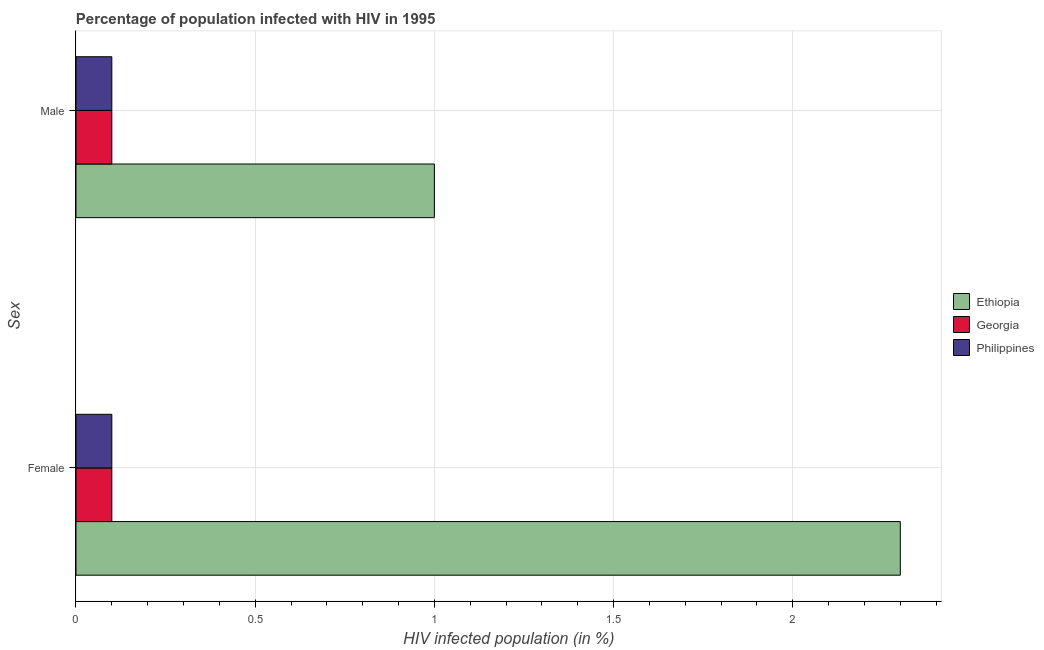Are the number of bars on each tick of the Y-axis equal?
Keep it short and to the point. Yes. How many bars are there on the 2nd tick from the bottom?
Your answer should be compact. 3. Across all countries, what is the minimum percentage of males who are infected with hiv?
Your answer should be very brief. 0.1. In which country was the percentage of males who are infected with hiv maximum?
Provide a succinct answer. Ethiopia. In which country was the percentage of females who are infected with hiv minimum?
Provide a short and direct response. Georgia. What is the total percentage of males who are infected with hiv in the graph?
Offer a very short reply. 1.2. What is the difference between the percentage of males who are infected with hiv in Philippines and the percentage of females who are infected with hiv in Georgia?
Make the answer very short. 0. What is the average percentage of females who are infected with hiv per country?
Offer a terse response. 0.83. What is the ratio of the percentage of males who are infected with hiv in Ethiopia to that in Philippines?
Provide a short and direct response. 10. What does the 2nd bar from the bottom in Male represents?
Offer a very short reply. Georgia. Are all the bars in the graph horizontal?
Your answer should be compact. Yes. How many countries are there in the graph?
Ensure brevity in your answer.  3. What is the difference between two consecutive major ticks on the X-axis?
Give a very brief answer. 0.5. Does the graph contain any zero values?
Offer a very short reply. No. Does the graph contain grids?
Make the answer very short. Yes. Where does the legend appear in the graph?
Your response must be concise. Center right. How many legend labels are there?
Your response must be concise. 3. How are the legend labels stacked?
Your answer should be compact. Vertical. What is the title of the graph?
Provide a short and direct response. Percentage of population infected with HIV in 1995. Does "Mauritania" appear as one of the legend labels in the graph?
Your answer should be very brief. No. What is the label or title of the X-axis?
Give a very brief answer. HIV infected population (in %). What is the label or title of the Y-axis?
Your answer should be compact. Sex. What is the HIV infected population (in %) in Ethiopia in Female?
Provide a succinct answer. 2.3. What is the HIV infected population (in %) in Georgia in Female?
Offer a terse response. 0.1. What is the HIV infected population (in %) in Philippines in Female?
Offer a very short reply. 0.1. What is the HIV infected population (in %) in Ethiopia in Male?
Your answer should be compact. 1. What is the HIV infected population (in %) in Georgia in Male?
Your answer should be compact. 0.1. What is the HIV infected population (in %) in Philippines in Male?
Your response must be concise. 0.1. Across all Sex, what is the maximum HIV infected population (in %) in Ethiopia?
Provide a short and direct response. 2.3. Across all Sex, what is the maximum HIV infected population (in %) in Georgia?
Provide a succinct answer. 0.1. Across all Sex, what is the maximum HIV infected population (in %) of Philippines?
Provide a short and direct response. 0.1. What is the total HIV infected population (in %) of Georgia in the graph?
Provide a succinct answer. 0.2. What is the difference between the HIV infected population (in %) of Georgia in Female and that in Male?
Your answer should be very brief. 0. What is the difference between the HIV infected population (in %) in Philippines in Female and that in Male?
Make the answer very short. 0. What is the difference between the HIV infected population (in %) of Ethiopia in Female and the HIV infected population (in %) of Georgia in Male?
Offer a terse response. 2.2. What is the difference between the HIV infected population (in %) of Ethiopia in Female and the HIV infected population (in %) of Philippines in Male?
Offer a terse response. 2.2. What is the average HIV infected population (in %) in Ethiopia per Sex?
Your answer should be very brief. 1.65. What is the difference between the HIV infected population (in %) of Georgia and HIV infected population (in %) of Philippines in Female?
Keep it short and to the point. 0. What is the difference between the HIV infected population (in %) in Ethiopia and HIV infected population (in %) in Georgia in Male?
Provide a succinct answer. 0.9. What is the difference between the HIV infected population (in %) of Georgia and HIV infected population (in %) of Philippines in Male?
Ensure brevity in your answer.  0. What is the ratio of the HIV infected population (in %) in Ethiopia in Female to that in Male?
Provide a succinct answer. 2.3. What is the ratio of the HIV infected population (in %) of Georgia in Female to that in Male?
Your answer should be compact. 1. What is the ratio of the HIV infected population (in %) in Philippines in Female to that in Male?
Give a very brief answer. 1. What is the difference between the highest and the lowest HIV infected population (in %) in Georgia?
Make the answer very short. 0. 